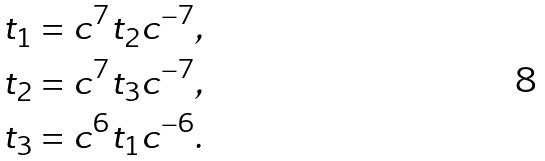<formula> <loc_0><loc_0><loc_500><loc_500>t _ { 1 } & = c ^ { 7 } t _ { 2 } c ^ { - 7 } , \\ t _ { 2 } & = c ^ { 7 } t _ { 3 } c ^ { - 7 } , \\ t _ { 3 } & = c ^ { 6 } t _ { 1 } c ^ { - 6 } .</formula> 